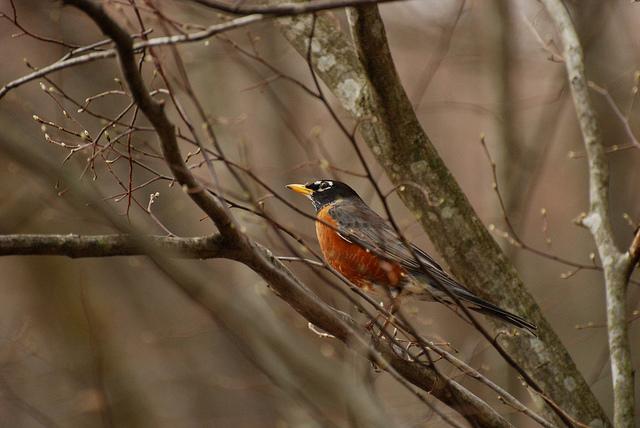Is this bird facing the Westerly direction?
Quick response, please. Yes. What kind of bird is this?
Be succinct. Robin. Is the bird making the branch?
Write a very short answer. No. Are the birds front feathers and beak the same exact color?
Be succinct. No. Is this a male or female bird?
Quick response, please. Male. What color is the bird?
Answer briefly. Red. 